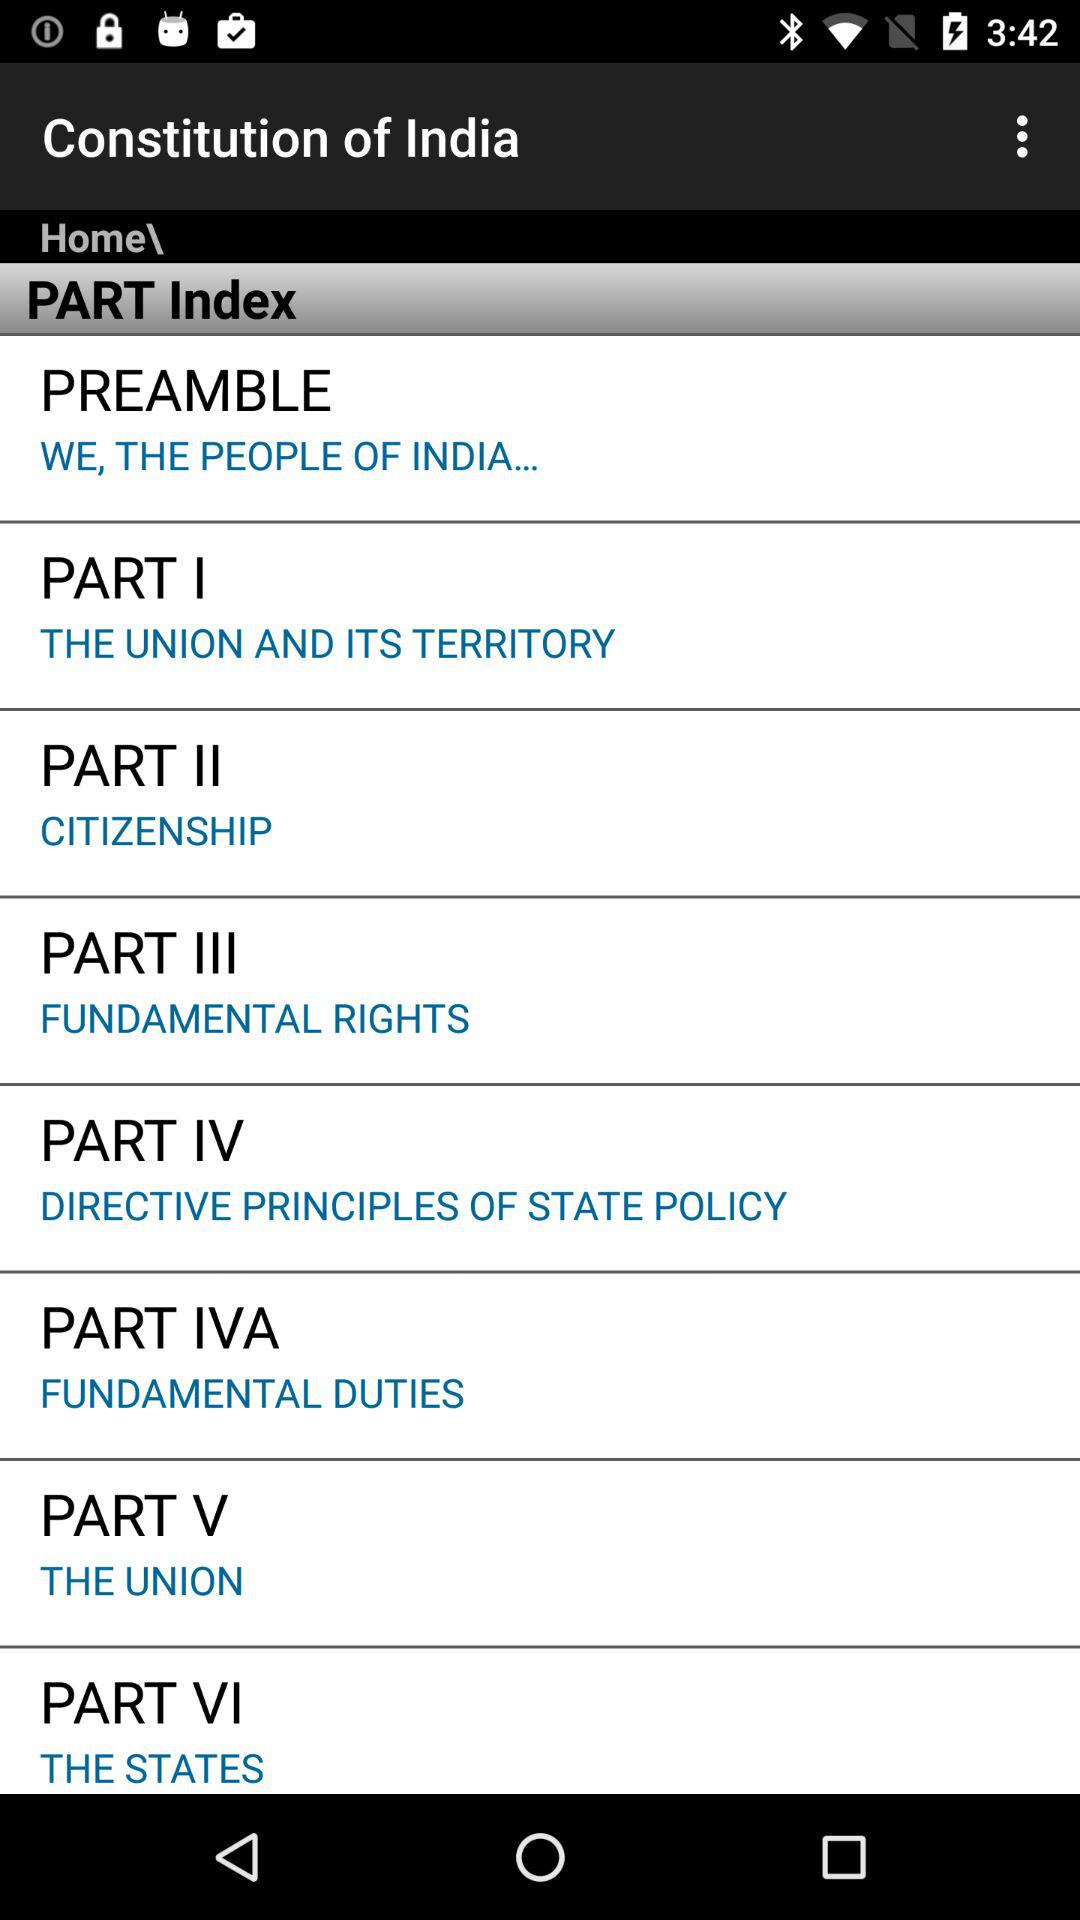Which part of India's constitution is represented by "THE STATES"? "THE STATES" represents Part VI of India's constitution. 